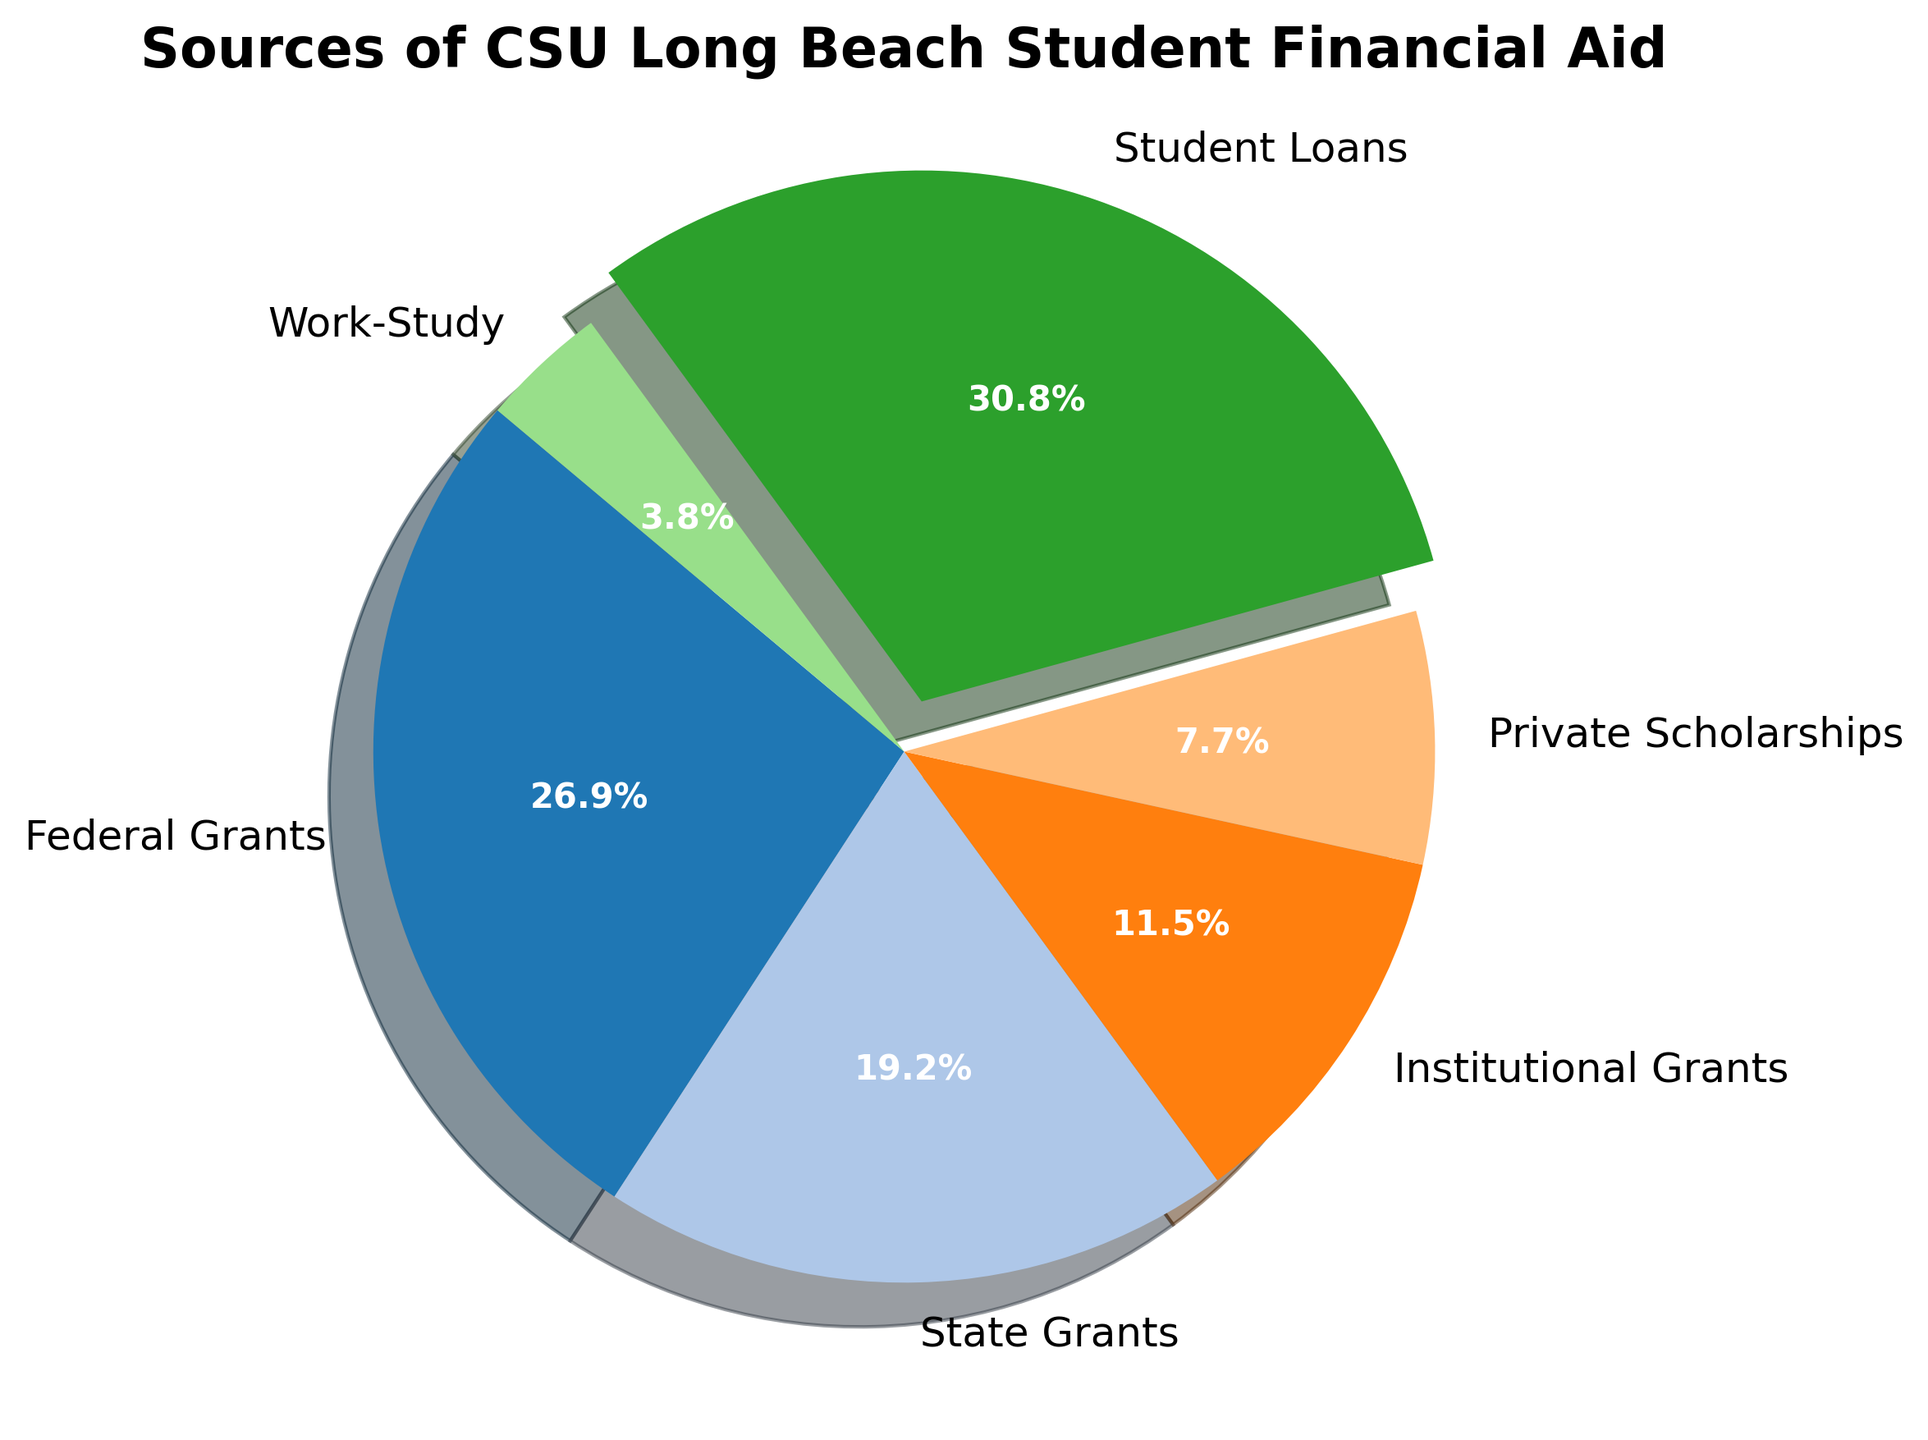Which source of financial aid contributes the largest amount? The pie chart highlights the slice for Student Loans, showing it prominently as the largest share. This indicates that Student Loans contribute the largest amount.
Answer: Student Loans Which source contributes the least to the financial aid? The smallest slice in the pie chart corresponds to Work-Study, making it the least contributing source.
Answer: Work-Study What percent of the total financial aid comes from Federal Grants? The pie chart slice labeled Federal Grants includes a percentage label showing 26.9%.
Answer: 26.9% How do the contributions of Federal and State Grants compare? The pie chart shows the slices for Federal Grants at 26.9% and State Grants at 19.3%. Comparing these, Federal Grants contribute more than State Grants.
Answer: Federal Grants contribute more What is the combined percentage of Institutional Grants and Private Scholarships? According to the pie chart, Institutional Grants are 11.5% and Private Scholarships are 7.7%. Summing these percentages gives 11.5% + 7.7% = 19.2%.
Answer: 19.2% Is the contribution from Student Loans greater than the combined contributions from State and Institutional Grants? The pie chart shows Student Loans at 30.8%. State Grants and Institutional Grants together are 19.3% + 11.5% = 30.8%. Comparing these, Student Loans and the combined contributions from State and Institutional Grants are equal.
Answer: Equal Which financial aid source is depicted with an exploded piece? In the pie chart, the slice that is exploded or emphasized is the one for Student Loans.
Answer: Student Loans What is the total percentage contributed by federal and state sources together? Federal Grants are 26.9% and State Grants are 19.3% as shown in the pie chart. Adding these gives 26.9% + 19.3% = 46.2%.
Answer: 46.2% If Institutional Grants are increased to match Federal Grants, what would their combined amount be? Federal Grants are $7,000,000 and Institutional Grants are $3,000,000 currently. Matching means increasing Institutional Grants to $7,000,000. Thus, the combined amount would be $7,000,000 (Federal) + $7,000,000 (Institutional) = $14,000,000.
Answer: $14,000,000 How does the contribution from Private Scholarships compare to Work-Study? The pie chart slice for Private Scholarships is 7.7%, whereas the slice for Work-Study is 3.8%. Thus, Private Scholarships contribute more than Work-Study.
Answer: Private Scholarships contribute more 